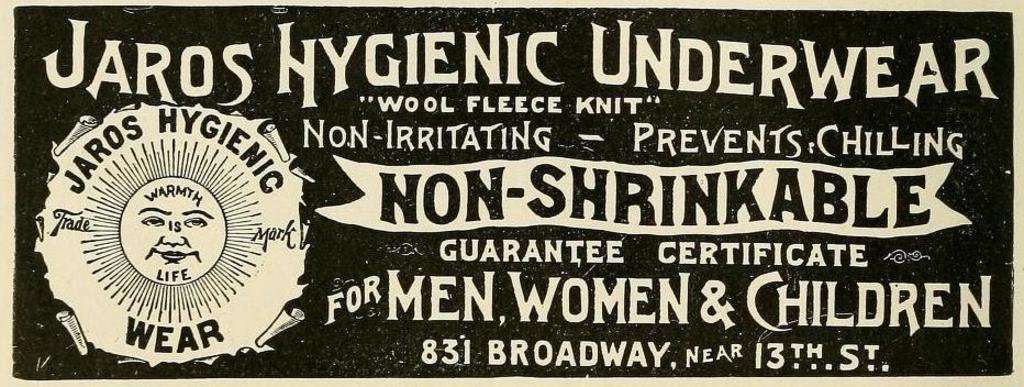What is present on the poster in the image? There is a poster in the image, which contains both text and an image. Can you describe the image on the poster? The provided facts do not give information about the image on the poster, so it cannot be described. What type of paint is being used to create trouble on the poster? There is no paint or indication of trouble present on the poster in the image. 